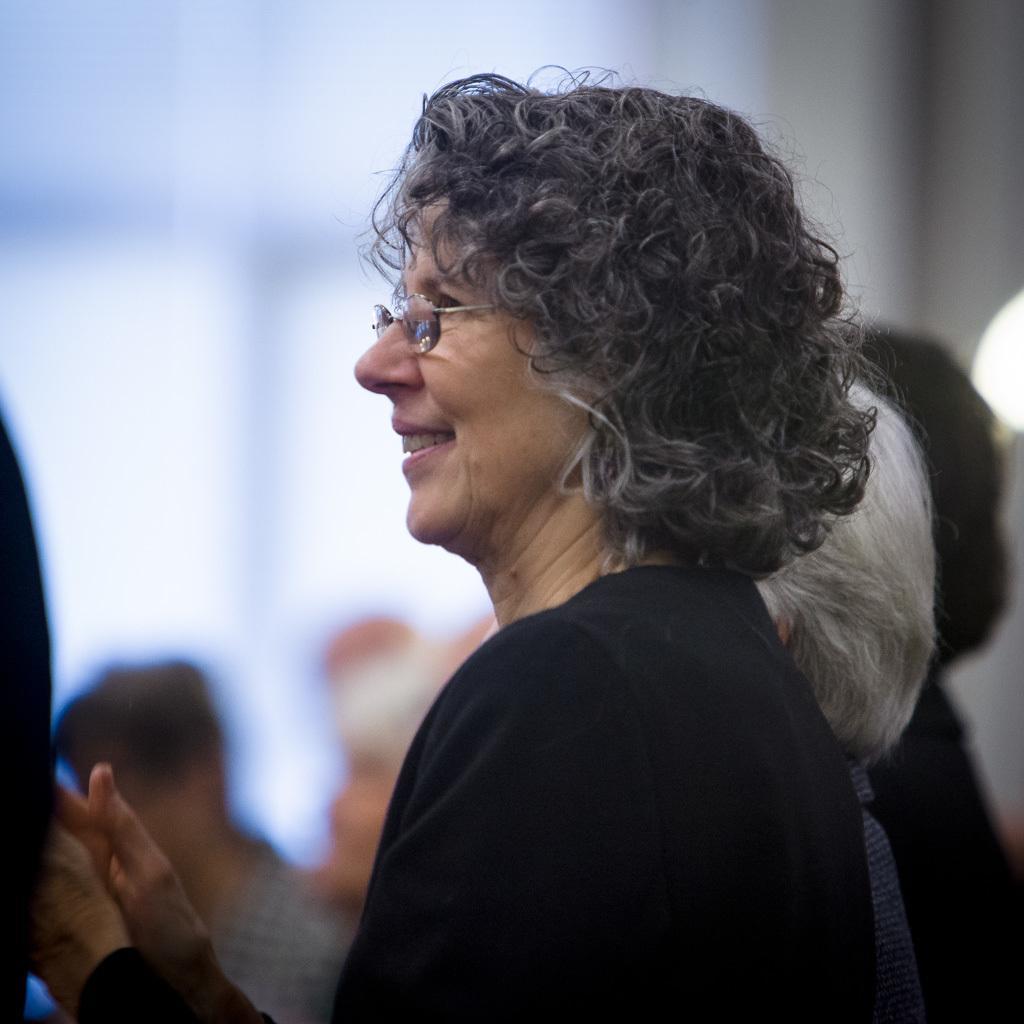Could you give a brief overview of what you see in this image? In this image, I can see a group of people. There is a blurred background. 